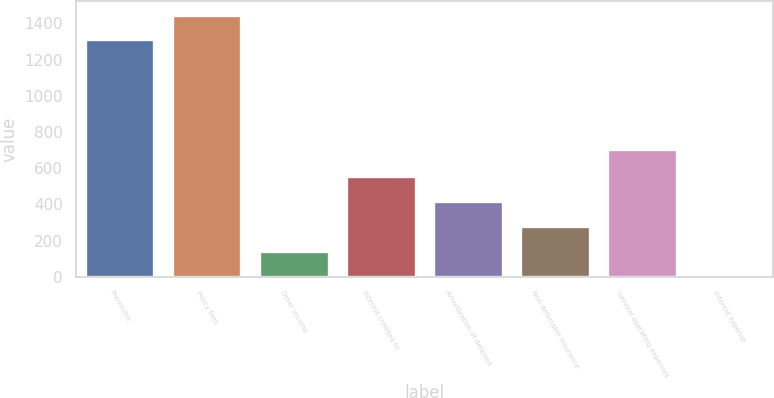Convert chart to OTSL. <chart><loc_0><loc_0><loc_500><loc_500><bar_chart><fcel>Premiums<fcel>Policy fees<fcel>Other income<fcel>Interest credited to<fcel>Amortization of deferred<fcel>Non deferrable insurance<fcel>General operating expenses<fcel>Interest expense<nl><fcel>1311<fcel>1448.2<fcel>144.2<fcel>555.8<fcel>418.6<fcel>281.4<fcel>707<fcel>7<nl></chart> 